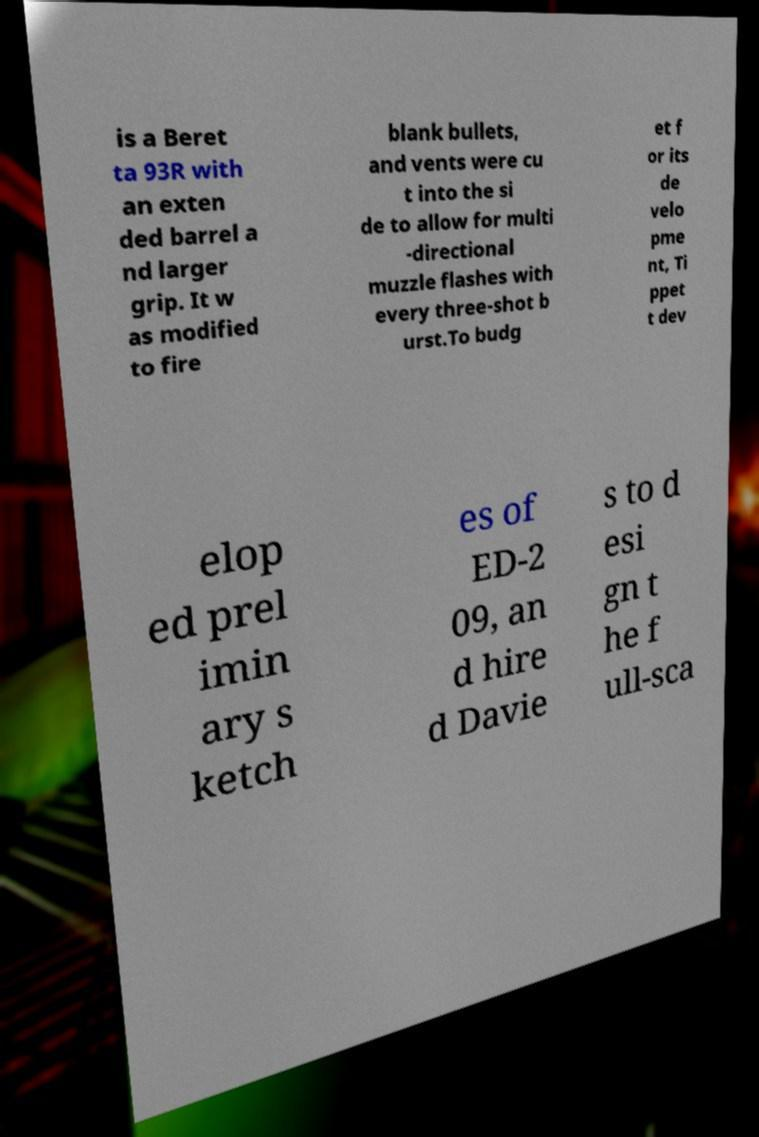Could you assist in decoding the text presented in this image and type it out clearly? is a Beret ta 93R with an exten ded barrel a nd larger grip. It w as modified to fire blank bullets, and vents were cu t into the si de to allow for multi -directional muzzle flashes with every three-shot b urst.To budg et f or its de velo pme nt, Ti ppet t dev elop ed prel imin ary s ketch es of ED-2 09, an d hire d Davie s to d esi gn t he f ull-sca 